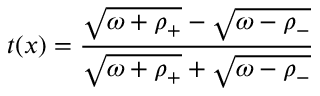Convert formula to latex. <formula><loc_0><loc_0><loc_500><loc_500>t ( x ) = { \frac { \sqrt { \omega + \rho _ { + } } - \sqrt { \omega - \rho _ { - } } } { \sqrt { \omega + \rho _ { + } } + \sqrt { \omega - \rho _ { - } } } }</formula> 